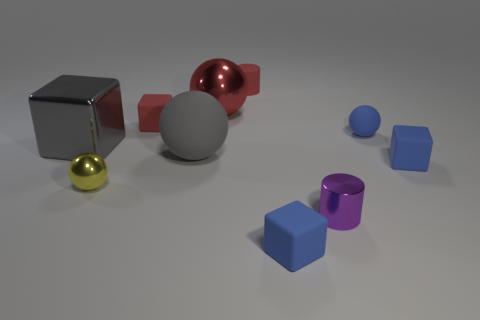Subtract 1 cubes. How many cubes are left? 3 Subtract all blocks. How many objects are left? 6 Add 8 gray cubes. How many gray cubes are left? 9 Add 5 tiny matte cylinders. How many tiny matte cylinders exist? 6 Subtract 0 blue cylinders. How many objects are left? 10 Subtract all red matte blocks. Subtract all tiny yellow metal balls. How many objects are left? 8 